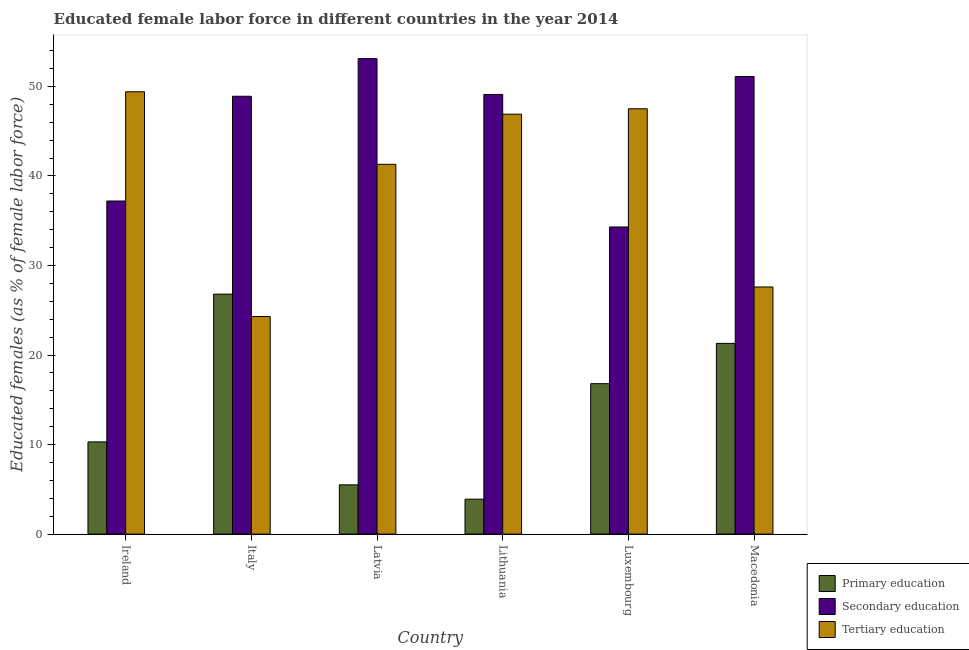How many groups of bars are there?
Keep it short and to the point. 6. Are the number of bars on each tick of the X-axis equal?
Your answer should be very brief. Yes. How many bars are there on the 6th tick from the left?
Give a very brief answer. 3. How many bars are there on the 6th tick from the right?
Your answer should be very brief. 3. What is the label of the 1st group of bars from the left?
Offer a terse response. Ireland. What is the percentage of female labor force who received primary education in Lithuania?
Make the answer very short. 3.9. Across all countries, what is the maximum percentage of female labor force who received primary education?
Keep it short and to the point. 26.8. Across all countries, what is the minimum percentage of female labor force who received tertiary education?
Your answer should be very brief. 24.3. In which country was the percentage of female labor force who received tertiary education maximum?
Provide a short and direct response. Ireland. What is the total percentage of female labor force who received tertiary education in the graph?
Provide a succinct answer. 237. What is the difference between the percentage of female labor force who received secondary education in Latvia and that in Luxembourg?
Your answer should be very brief. 18.8. What is the difference between the percentage of female labor force who received primary education in Luxembourg and the percentage of female labor force who received secondary education in Ireland?
Offer a terse response. -20.4. What is the average percentage of female labor force who received secondary education per country?
Give a very brief answer. 45.62. What is the difference between the percentage of female labor force who received primary education and percentage of female labor force who received secondary education in Ireland?
Keep it short and to the point. -26.9. What is the ratio of the percentage of female labor force who received tertiary education in Luxembourg to that in Macedonia?
Your answer should be compact. 1.72. Is the percentage of female labor force who received tertiary education in Ireland less than that in Latvia?
Provide a succinct answer. No. Is the difference between the percentage of female labor force who received secondary education in Italy and Luxembourg greater than the difference between the percentage of female labor force who received tertiary education in Italy and Luxembourg?
Give a very brief answer. Yes. What is the difference between the highest and the second highest percentage of female labor force who received tertiary education?
Give a very brief answer. 1.9. What is the difference between the highest and the lowest percentage of female labor force who received primary education?
Make the answer very short. 22.9. In how many countries, is the percentage of female labor force who received tertiary education greater than the average percentage of female labor force who received tertiary education taken over all countries?
Provide a succinct answer. 4. What does the 1st bar from the left in Latvia represents?
Offer a terse response. Primary education. What does the 2nd bar from the right in Latvia represents?
Provide a short and direct response. Secondary education. Is it the case that in every country, the sum of the percentage of female labor force who received primary education and percentage of female labor force who received secondary education is greater than the percentage of female labor force who received tertiary education?
Provide a short and direct response. No. How many countries are there in the graph?
Offer a very short reply. 6. What is the difference between two consecutive major ticks on the Y-axis?
Offer a terse response. 10. Are the values on the major ticks of Y-axis written in scientific E-notation?
Offer a very short reply. No. Does the graph contain any zero values?
Offer a terse response. No. How many legend labels are there?
Your answer should be compact. 3. How are the legend labels stacked?
Offer a very short reply. Vertical. What is the title of the graph?
Offer a very short reply. Educated female labor force in different countries in the year 2014. Does "Solid fuel" appear as one of the legend labels in the graph?
Provide a short and direct response. No. What is the label or title of the X-axis?
Provide a short and direct response. Country. What is the label or title of the Y-axis?
Give a very brief answer. Educated females (as % of female labor force). What is the Educated females (as % of female labor force) in Primary education in Ireland?
Provide a short and direct response. 10.3. What is the Educated females (as % of female labor force) of Secondary education in Ireland?
Provide a short and direct response. 37.2. What is the Educated females (as % of female labor force) in Tertiary education in Ireland?
Provide a short and direct response. 49.4. What is the Educated females (as % of female labor force) of Primary education in Italy?
Provide a succinct answer. 26.8. What is the Educated females (as % of female labor force) in Secondary education in Italy?
Ensure brevity in your answer.  48.9. What is the Educated females (as % of female labor force) in Tertiary education in Italy?
Your answer should be compact. 24.3. What is the Educated females (as % of female labor force) in Secondary education in Latvia?
Provide a short and direct response. 53.1. What is the Educated females (as % of female labor force) of Tertiary education in Latvia?
Your answer should be very brief. 41.3. What is the Educated females (as % of female labor force) of Primary education in Lithuania?
Your response must be concise. 3.9. What is the Educated females (as % of female labor force) in Secondary education in Lithuania?
Make the answer very short. 49.1. What is the Educated females (as % of female labor force) of Tertiary education in Lithuania?
Offer a very short reply. 46.9. What is the Educated females (as % of female labor force) of Primary education in Luxembourg?
Provide a succinct answer. 16.8. What is the Educated females (as % of female labor force) of Secondary education in Luxembourg?
Your answer should be very brief. 34.3. What is the Educated females (as % of female labor force) of Tertiary education in Luxembourg?
Offer a very short reply. 47.5. What is the Educated females (as % of female labor force) in Primary education in Macedonia?
Your answer should be compact. 21.3. What is the Educated females (as % of female labor force) of Secondary education in Macedonia?
Offer a terse response. 51.1. What is the Educated females (as % of female labor force) in Tertiary education in Macedonia?
Your answer should be compact. 27.6. Across all countries, what is the maximum Educated females (as % of female labor force) of Primary education?
Your answer should be very brief. 26.8. Across all countries, what is the maximum Educated females (as % of female labor force) of Secondary education?
Ensure brevity in your answer.  53.1. Across all countries, what is the maximum Educated females (as % of female labor force) of Tertiary education?
Your answer should be compact. 49.4. Across all countries, what is the minimum Educated females (as % of female labor force) in Primary education?
Provide a short and direct response. 3.9. Across all countries, what is the minimum Educated females (as % of female labor force) of Secondary education?
Give a very brief answer. 34.3. Across all countries, what is the minimum Educated females (as % of female labor force) in Tertiary education?
Offer a terse response. 24.3. What is the total Educated females (as % of female labor force) in Primary education in the graph?
Make the answer very short. 84.6. What is the total Educated females (as % of female labor force) of Secondary education in the graph?
Your response must be concise. 273.7. What is the total Educated females (as % of female labor force) of Tertiary education in the graph?
Provide a short and direct response. 237. What is the difference between the Educated females (as % of female labor force) in Primary education in Ireland and that in Italy?
Ensure brevity in your answer.  -16.5. What is the difference between the Educated females (as % of female labor force) in Tertiary education in Ireland and that in Italy?
Provide a short and direct response. 25.1. What is the difference between the Educated females (as % of female labor force) of Primary education in Ireland and that in Latvia?
Offer a terse response. 4.8. What is the difference between the Educated females (as % of female labor force) in Secondary education in Ireland and that in Latvia?
Make the answer very short. -15.9. What is the difference between the Educated females (as % of female labor force) of Secondary education in Ireland and that in Luxembourg?
Your answer should be very brief. 2.9. What is the difference between the Educated females (as % of female labor force) in Primary education in Ireland and that in Macedonia?
Provide a short and direct response. -11. What is the difference between the Educated females (as % of female labor force) of Tertiary education in Ireland and that in Macedonia?
Your response must be concise. 21.8. What is the difference between the Educated females (as % of female labor force) of Primary education in Italy and that in Latvia?
Offer a very short reply. 21.3. What is the difference between the Educated females (as % of female labor force) of Primary education in Italy and that in Lithuania?
Give a very brief answer. 22.9. What is the difference between the Educated females (as % of female labor force) in Tertiary education in Italy and that in Lithuania?
Your answer should be compact. -22.6. What is the difference between the Educated females (as % of female labor force) in Tertiary education in Italy and that in Luxembourg?
Give a very brief answer. -23.2. What is the difference between the Educated females (as % of female labor force) in Tertiary education in Italy and that in Macedonia?
Keep it short and to the point. -3.3. What is the difference between the Educated females (as % of female labor force) of Secondary education in Latvia and that in Lithuania?
Your answer should be very brief. 4. What is the difference between the Educated females (as % of female labor force) in Primary education in Latvia and that in Luxembourg?
Ensure brevity in your answer.  -11.3. What is the difference between the Educated females (as % of female labor force) in Primary education in Latvia and that in Macedonia?
Offer a terse response. -15.8. What is the difference between the Educated females (as % of female labor force) of Primary education in Lithuania and that in Luxembourg?
Ensure brevity in your answer.  -12.9. What is the difference between the Educated females (as % of female labor force) of Primary education in Lithuania and that in Macedonia?
Provide a short and direct response. -17.4. What is the difference between the Educated females (as % of female labor force) in Secondary education in Lithuania and that in Macedonia?
Provide a succinct answer. -2. What is the difference between the Educated females (as % of female labor force) of Tertiary education in Lithuania and that in Macedonia?
Keep it short and to the point. 19.3. What is the difference between the Educated females (as % of female labor force) in Primary education in Luxembourg and that in Macedonia?
Your answer should be compact. -4.5. What is the difference between the Educated females (as % of female labor force) in Secondary education in Luxembourg and that in Macedonia?
Offer a very short reply. -16.8. What is the difference between the Educated females (as % of female labor force) of Primary education in Ireland and the Educated females (as % of female labor force) of Secondary education in Italy?
Make the answer very short. -38.6. What is the difference between the Educated females (as % of female labor force) of Primary education in Ireland and the Educated females (as % of female labor force) of Tertiary education in Italy?
Provide a short and direct response. -14. What is the difference between the Educated females (as % of female labor force) in Secondary education in Ireland and the Educated females (as % of female labor force) in Tertiary education in Italy?
Offer a terse response. 12.9. What is the difference between the Educated females (as % of female labor force) of Primary education in Ireland and the Educated females (as % of female labor force) of Secondary education in Latvia?
Keep it short and to the point. -42.8. What is the difference between the Educated females (as % of female labor force) of Primary education in Ireland and the Educated females (as % of female labor force) of Tertiary education in Latvia?
Your response must be concise. -31. What is the difference between the Educated females (as % of female labor force) in Primary education in Ireland and the Educated females (as % of female labor force) in Secondary education in Lithuania?
Provide a short and direct response. -38.8. What is the difference between the Educated females (as % of female labor force) in Primary education in Ireland and the Educated females (as % of female labor force) in Tertiary education in Lithuania?
Your answer should be compact. -36.6. What is the difference between the Educated females (as % of female labor force) of Primary education in Ireland and the Educated females (as % of female labor force) of Tertiary education in Luxembourg?
Offer a terse response. -37.2. What is the difference between the Educated females (as % of female labor force) in Secondary education in Ireland and the Educated females (as % of female labor force) in Tertiary education in Luxembourg?
Provide a short and direct response. -10.3. What is the difference between the Educated females (as % of female labor force) in Primary education in Ireland and the Educated females (as % of female labor force) in Secondary education in Macedonia?
Your response must be concise. -40.8. What is the difference between the Educated females (as % of female labor force) of Primary education in Ireland and the Educated females (as % of female labor force) of Tertiary education in Macedonia?
Your answer should be very brief. -17.3. What is the difference between the Educated females (as % of female labor force) in Primary education in Italy and the Educated females (as % of female labor force) in Secondary education in Latvia?
Your answer should be compact. -26.3. What is the difference between the Educated females (as % of female labor force) in Primary education in Italy and the Educated females (as % of female labor force) in Secondary education in Lithuania?
Offer a very short reply. -22.3. What is the difference between the Educated females (as % of female labor force) in Primary education in Italy and the Educated females (as % of female labor force) in Tertiary education in Lithuania?
Provide a short and direct response. -20.1. What is the difference between the Educated females (as % of female labor force) in Primary education in Italy and the Educated females (as % of female labor force) in Tertiary education in Luxembourg?
Offer a very short reply. -20.7. What is the difference between the Educated females (as % of female labor force) in Primary education in Italy and the Educated females (as % of female labor force) in Secondary education in Macedonia?
Ensure brevity in your answer.  -24.3. What is the difference between the Educated females (as % of female labor force) in Secondary education in Italy and the Educated females (as % of female labor force) in Tertiary education in Macedonia?
Give a very brief answer. 21.3. What is the difference between the Educated females (as % of female labor force) in Primary education in Latvia and the Educated females (as % of female labor force) in Secondary education in Lithuania?
Give a very brief answer. -43.6. What is the difference between the Educated females (as % of female labor force) in Primary education in Latvia and the Educated females (as % of female labor force) in Tertiary education in Lithuania?
Offer a very short reply. -41.4. What is the difference between the Educated females (as % of female labor force) of Primary education in Latvia and the Educated females (as % of female labor force) of Secondary education in Luxembourg?
Your answer should be very brief. -28.8. What is the difference between the Educated females (as % of female labor force) of Primary education in Latvia and the Educated females (as % of female labor force) of Tertiary education in Luxembourg?
Offer a terse response. -42. What is the difference between the Educated females (as % of female labor force) of Secondary education in Latvia and the Educated females (as % of female labor force) of Tertiary education in Luxembourg?
Make the answer very short. 5.6. What is the difference between the Educated females (as % of female labor force) of Primary education in Latvia and the Educated females (as % of female labor force) of Secondary education in Macedonia?
Make the answer very short. -45.6. What is the difference between the Educated females (as % of female labor force) in Primary education in Latvia and the Educated females (as % of female labor force) in Tertiary education in Macedonia?
Provide a short and direct response. -22.1. What is the difference between the Educated females (as % of female labor force) of Secondary education in Latvia and the Educated females (as % of female labor force) of Tertiary education in Macedonia?
Provide a short and direct response. 25.5. What is the difference between the Educated females (as % of female labor force) in Primary education in Lithuania and the Educated females (as % of female labor force) in Secondary education in Luxembourg?
Your answer should be compact. -30.4. What is the difference between the Educated females (as % of female labor force) of Primary education in Lithuania and the Educated females (as % of female labor force) of Tertiary education in Luxembourg?
Ensure brevity in your answer.  -43.6. What is the difference between the Educated females (as % of female labor force) in Secondary education in Lithuania and the Educated females (as % of female labor force) in Tertiary education in Luxembourg?
Keep it short and to the point. 1.6. What is the difference between the Educated females (as % of female labor force) of Primary education in Lithuania and the Educated females (as % of female labor force) of Secondary education in Macedonia?
Your answer should be very brief. -47.2. What is the difference between the Educated females (as % of female labor force) of Primary education in Lithuania and the Educated females (as % of female labor force) of Tertiary education in Macedonia?
Provide a short and direct response. -23.7. What is the difference between the Educated females (as % of female labor force) of Secondary education in Lithuania and the Educated females (as % of female labor force) of Tertiary education in Macedonia?
Your response must be concise. 21.5. What is the difference between the Educated females (as % of female labor force) in Primary education in Luxembourg and the Educated females (as % of female labor force) in Secondary education in Macedonia?
Your answer should be very brief. -34.3. What is the average Educated females (as % of female labor force) in Primary education per country?
Provide a succinct answer. 14.1. What is the average Educated females (as % of female labor force) of Secondary education per country?
Give a very brief answer. 45.62. What is the average Educated females (as % of female labor force) of Tertiary education per country?
Provide a succinct answer. 39.5. What is the difference between the Educated females (as % of female labor force) of Primary education and Educated females (as % of female labor force) of Secondary education in Ireland?
Keep it short and to the point. -26.9. What is the difference between the Educated females (as % of female labor force) in Primary education and Educated females (as % of female labor force) in Tertiary education in Ireland?
Give a very brief answer. -39.1. What is the difference between the Educated females (as % of female labor force) of Secondary education and Educated females (as % of female labor force) of Tertiary education in Ireland?
Ensure brevity in your answer.  -12.2. What is the difference between the Educated females (as % of female labor force) of Primary education and Educated females (as % of female labor force) of Secondary education in Italy?
Make the answer very short. -22.1. What is the difference between the Educated females (as % of female labor force) of Secondary education and Educated females (as % of female labor force) of Tertiary education in Italy?
Give a very brief answer. 24.6. What is the difference between the Educated females (as % of female labor force) of Primary education and Educated females (as % of female labor force) of Secondary education in Latvia?
Make the answer very short. -47.6. What is the difference between the Educated females (as % of female labor force) of Primary education and Educated females (as % of female labor force) of Tertiary education in Latvia?
Provide a short and direct response. -35.8. What is the difference between the Educated females (as % of female labor force) in Primary education and Educated females (as % of female labor force) in Secondary education in Lithuania?
Offer a very short reply. -45.2. What is the difference between the Educated females (as % of female labor force) in Primary education and Educated females (as % of female labor force) in Tertiary education in Lithuania?
Keep it short and to the point. -43. What is the difference between the Educated females (as % of female labor force) in Primary education and Educated females (as % of female labor force) in Secondary education in Luxembourg?
Keep it short and to the point. -17.5. What is the difference between the Educated females (as % of female labor force) in Primary education and Educated females (as % of female labor force) in Tertiary education in Luxembourg?
Offer a terse response. -30.7. What is the difference between the Educated females (as % of female labor force) in Secondary education and Educated females (as % of female labor force) in Tertiary education in Luxembourg?
Ensure brevity in your answer.  -13.2. What is the difference between the Educated females (as % of female labor force) in Primary education and Educated females (as % of female labor force) in Secondary education in Macedonia?
Ensure brevity in your answer.  -29.8. What is the difference between the Educated females (as % of female labor force) in Primary education and Educated females (as % of female labor force) in Tertiary education in Macedonia?
Your answer should be very brief. -6.3. What is the difference between the Educated females (as % of female labor force) of Secondary education and Educated females (as % of female labor force) of Tertiary education in Macedonia?
Give a very brief answer. 23.5. What is the ratio of the Educated females (as % of female labor force) in Primary education in Ireland to that in Italy?
Give a very brief answer. 0.38. What is the ratio of the Educated females (as % of female labor force) of Secondary education in Ireland to that in Italy?
Provide a succinct answer. 0.76. What is the ratio of the Educated females (as % of female labor force) of Tertiary education in Ireland to that in Italy?
Your answer should be compact. 2.03. What is the ratio of the Educated females (as % of female labor force) of Primary education in Ireland to that in Latvia?
Provide a succinct answer. 1.87. What is the ratio of the Educated females (as % of female labor force) in Secondary education in Ireland to that in Latvia?
Ensure brevity in your answer.  0.7. What is the ratio of the Educated females (as % of female labor force) of Tertiary education in Ireland to that in Latvia?
Offer a terse response. 1.2. What is the ratio of the Educated females (as % of female labor force) of Primary education in Ireland to that in Lithuania?
Ensure brevity in your answer.  2.64. What is the ratio of the Educated females (as % of female labor force) in Secondary education in Ireland to that in Lithuania?
Provide a succinct answer. 0.76. What is the ratio of the Educated females (as % of female labor force) of Tertiary education in Ireland to that in Lithuania?
Make the answer very short. 1.05. What is the ratio of the Educated females (as % of female labor force) in Primary education in Ireland to that in Luxembourg?
Give a very brief answer. 0.61. What is the ratio of the Educated females (as % of female labor force) of Secondary education in Ireland to that in Luxembourg?
Give a very brief answer. 1.08. What is the ratio of the Educated females (as % of female labor force) in Tertiary education in Ireland to that in Luxembourg?
Your answer should be very brief. 1.04. What is the ratio of the Educated females (as % of female labor force) in Primary education in Ireland to that in Macedonia?
Ensure brevity in your answer.  0.48. What is the ratio of the Educated females (as % of female labor force) of Secondary education in Ireland to that in Macedonia?
Offer a terse response. 0.73. What is the ratio of the Educated females (as % of female labor force) in Tertiary education in Ireland to that in Macedonia?
Offer a terse response. 1.79. What is the ratio of the Educated females (as % of female labor force) of Primary education in Italy to that in Latvia?
Your answer should be compact. 4.87. What is the ratio of the Educated females (as % of female labor force) in Secondary education in Italy to that in Latvia?
Your answer should be compact. 0.92. What is the ratio of the Educated females (as % of female labor force) of Tertiary education in Italy to that in Latvia?
Keep it short and to the point. 0.59. What is the ratio of the Educated females (as % of female labor force) in Primary education in Italy to that in Lithuania?
Your response must be concise. 6.87. What is the ratio of the Educated females (as % of female labor force) of Secondary education in Italy to that in Lithuania?
Your response must be concise. 1. What is the ratio of the Educated females (as % of female labor force) of Tertiary education in Italy to that in Lithuania?
Make the answer very short. 0.52. What is the ratio of the Educated females (as % of female labor force) of Primary education in Italy to that in Luxembourg?
Give a very brief answer. 1.6. What is the ratio of the Educated females (as % of female labor force) in Secondary education in Italy to that in Luxembourg?
Your answer should be compact. 1.43. What is the ratio of the Educated females (as % of female labor force) of Tertiary education in Italy to that in Luxembourg?
Offer a terse response. 0.51. What is the ratio of the Educated females (as % of female labor force) of Primary education in Italy to that in Macedonia?
Offer a terse response. 1.26. What is the ratio of the Educated females (as % of female labor force) in Secondary education in Italy to that in Macedonia?
Provide a succinct answer. 0.96. What is the ratio of the Educated females (as % of female labor force) of Tertiary education in Italy to that in Macedonia?
Provide a succinct answer. 0.88. What is the ratio of the Educated females (as % of female labor force) in Primary education in Latvia to that in Lithuania?
Offer a terse response. 1.41. What is the ratio of the Educated females (as % of female labor force) in Secondary education in Latvia to that in Lithuania?
Your answer should be very brief. 1.08. What is the ratio of the Educated females (as % of female labor force) in Tertiary education in Latvia to that in Lithuania?
Keep it short and to the point. 0.88. What is the ratio of the Educated females (as % of female labor force) in Primary education in Latvia to that in Luxembourg?
Your answer should be very brief. 0.33. What is the ratio of the Educated females (as % of female labor force) in Secondary education in Latvia to that in Luxembourg?
Keep it short and to the point. 1.55. What is the ratio of the Educated females (as % of female labor force) of Tertiary education in Latvia to that in Luxembourg?
Offer a very short reply. 0.87. What is the ratio of the Educated females (as % of female labor force) of Primary education in Latvia to that in Macedonia?
Give a very brief answer. 0.26. What is the ratio of the Educated females (as % of female labor force) of Secondary education in Latvia to that in Macedonia?
Provide a short and direct response. 1.04. What is the ratio of the Educated females (as % of female labor force) of Tertiary education in Latvia to that in Macedonia?
Make the answer very short. 1.5. What is the ratio of the Educated females (as % of female labor force) in Primary education in Lithuania to that in Luxembourg?
Your answer should be compact. 0.23. What is the ratio of the Educated females (as % of female labor force) of Secondary education in Lithuania to that in Luxembourg?
Your answer should be very brief. 1.43. What is the ratio of the Educated females (as % of female labor force) of Tertiary education in Lithuania to that in Luxembourg?
Provide a succinct answer. 0.99. What is the ratio of the Educated females (as % of female labor force) of Primary education in Lithuania to that in Macedonia?
Keep it short and to the point. 0.18. What is the ratio of the Educated females (as % of female labor force) in Secondary education in Lithuania to that in Macedonia?
Offer a very short reply. 0.96. What is the ratio of the Educated females (as % of female labor force) in Tertiary education in Lithuania to that in Macedonia?
Your answer should be compact. 1.7. What is the ratio of the Educated females (as % of female labor force) of Primary education in Luxembourg to that in Macedonia?
Your response must be concise. 0.79. What is the ratio of the Educated females (as % of female labor force) in Secondary education in Luxembourg to that in Macedonia?
Provide a succinct answer. 0.67. What is the ratio of the Educated females (as % of female labor force) in Tertiary education in Luxembourg to that in Macedonia?
Ensure brevity in your answer.  1.72. What is the difference between the highest and the second highest Educated females (as % of female labor force) of Tertiary education?
Ensure brevity in your answer.  1.9. What is the difference between the highest and the lowest Educated females (as % of female labor force) of Primary education?
Ensure brevity in your answer.  22.9. What is the difference between the highest and the lowest Educated females (as % of female labor force) in Tertiary education?
Make the answer very short. 25.1. 